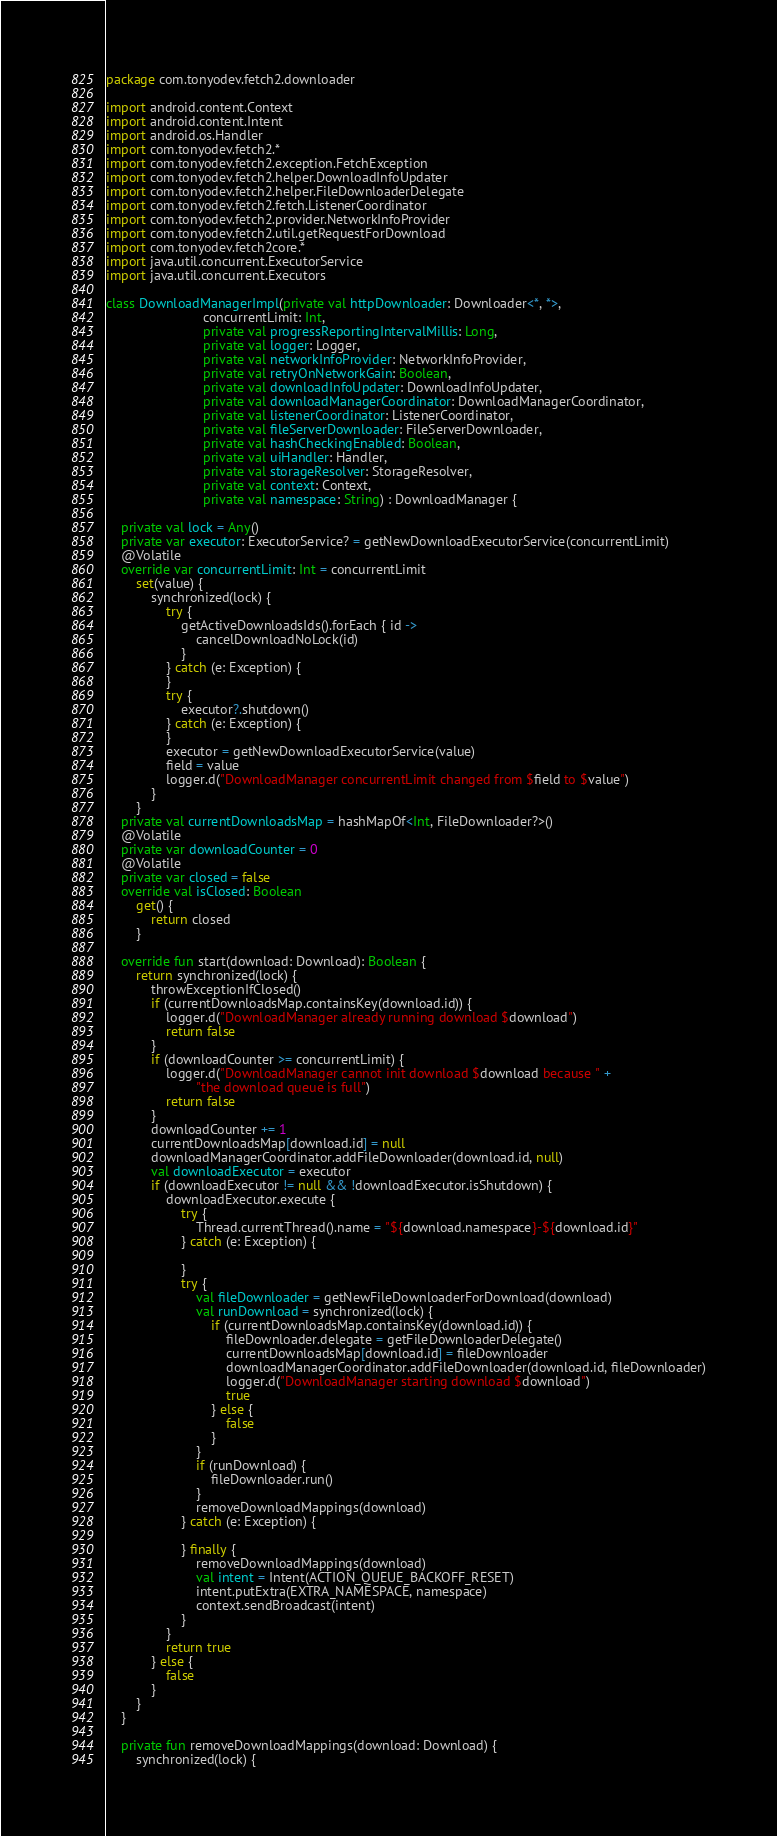Convert code to text. <code><loc_0><loc_0><loc_500><loc_500><_Kotlin_>package com.tonyodev.fetch2.downloader

import android.content.Context
import android.content.Intent
import android.os.Handler
import com.tonyodev.fetch2.*
import com.tonyodev.fetch2.exception.FetchException
import com.tonyodev.fetch2.helper.DownloadInfoUpdater
import com.tonyodev.fetch2.helper.FileDownloaderDelegate
import com.tonyodev.fetch2.fetch.ListenerCoordinator
import com.tonyodev.fetch2.provider.NetworkInfoProvider
import com.tonyodev.fetch2.util.getRequestForDownload
import com.tonyodev.fetch2core.*
import java.util.concurrent.ExecutorService
import java.util.concurrent.Executors

class DownloadManagerImpl(private val httpDownloader: Downloader<*, *>,
                          concurrentLimit: Int,
                          private val progressReportingIntervalMillis: Long,
                          private val logger: Logger,
                          private val networkInfoProvider: NetworkInfoProvider,
                          private val retryOnNetworkGain: Boolean,
                          private val downloadInfoUpdater: DownloadInfoUpdater,
                          private val downloadManagerCoordinator: DownloadManagerCoordinator,
                          private val listenerCoordinator: ListenerCoordinator,
                          private val fileServerDownloader: FileServerDownloader,
                          private val hashCheckingEnabled: Boolean,
                          private val uiHandler: Handler,
                          private val storageResolver: StorageResolver,
                          private val context: Context,
                          private val namespace: String) : DownloadManager {

    private val lock = Any()
    private var executor: ExecutorService? = getNewDownloadExecutorService(concurrentLimit)
    @Volatile
    override var concurrentLimit: Int = concurrentLimit
        set(value) {
            synchronized(lock) {
                try {
                    getActiveDownloadsIds().forEach { id ->
                        cancelDownloadNoLock(id)
                    }
                } catch (e: Exception) {
                }
                try {
                    executor?.shutdown()
                } catch (e: Exception) {
                }
                executor = getNewDownloadExecutorService(value)
                field = value
                logger.d("DownloadManager concurrentLimit changed from $field to $value")
            }
        }
    private val currentDownloadsMap = hashMapOf<Int, FileDownloader?>()
    @Volatile
    private var downloadCounter = 0
    @Volatile
    private var closed = false
    override val isClosed: Boolean
        get() {
            return closed
        }

    override fun start(download: Download): Boolean {
        return synchronized(lock) {
            throwExceptionIfClosed()
            if (currentDownloadsMap.containsKey(download.id)) {
                logger.d("DownloadManager already running download $download")
                return false
            }
            if (downloadCounter >= concurrentLimit) {
                logger.d("DownloadManager cannot init download $download because " +
                        "the download queue is full")
                return false
            }
            downloadCounter += 1
            currentDownloadsMap[download.id] = null
            downloadManagerCoordinator.addFileDownloader(download.id, null)
            val downloadExecutor = executor
            if (downloadExecutor != null && !downloadExecutor.isShutdown) {
                downloadExecutor.execute {
                    try {
                        Thread.currentThread().name = "${download.namespace}-${download.id}"
                    } catch (e: Exception) {

                    }
                    try {
                        val fileDownloader = getNewFileDownloaderForDownload(download)
                        val runDownload = synchronized(lock) {
                            if (currentDownloadsMap.containsKey(download.id)) {
                                fileDownloader.delegate = getFileDownloaderDelegate()
                                currentDownloadsMap[download.id] = fileDownloader
                                downloadManagerCoordinator.addFileDownloader(download.id, fileDownloader)
                                logger.d("DownloadManager starting download $download")
                                true
                            } else {
                                false
                            }
                        }
                        if (runDownload) {
                            fileDownloader.run()
                        }
                        removeDownloadMappings(download)
                    } catch (e: Exception) {

                    } finally {
                        removeDownloadMappings(download)
                        val intent = Intent(ACTION_QUEUE_BACKOFF_RESET)
                        intent.putExtra(EXTRA_NAMESPACE, namespace)
                        context.sendBroadcast(intent)
                    }
                }
                return true
            } else {
                false
            }
        }
    }

    private fun removeDownloadMappings(download: Download) {
        synchronized(lock) {</code> 